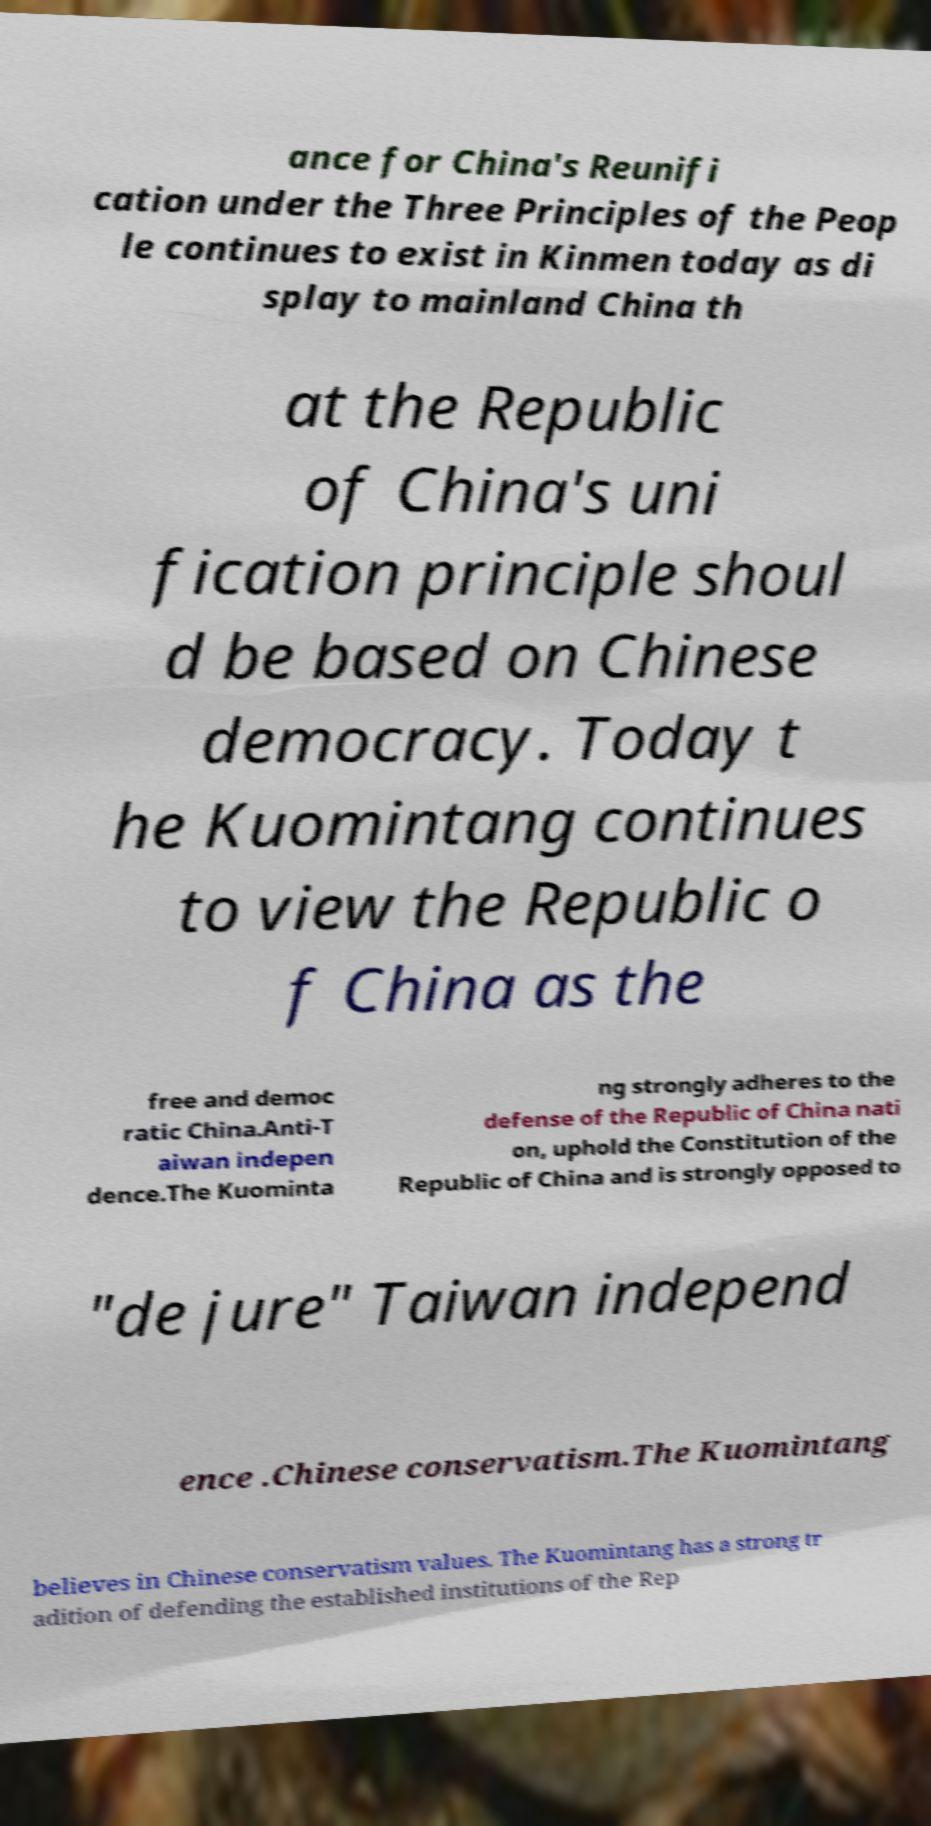I need the written content from this picture converted into text. Can you do that? ance for China's Reunifi cation under the Three Principles of the Peop le continues to exist in Kinmen today as di splay to mainland China th at the Republic of China's uni fication principle shoul d be based on Chinese democracy. Today t he Kuomintang continues to view the Republic o f China as the free and democ ratic China.Anti-T aiwan indepen dence.The Kuominta ng strongly adheres to the defense of the Republic of China nati on, uphold the Constitution of the Republic of China and is strongly opposed to "de jure" Taiwan independ ence .Chinese conservatism.The Kuomintang believes in Chinese conservatism values. The Kuomintang has a strong tr adition of defending the established institutions of the Rep 